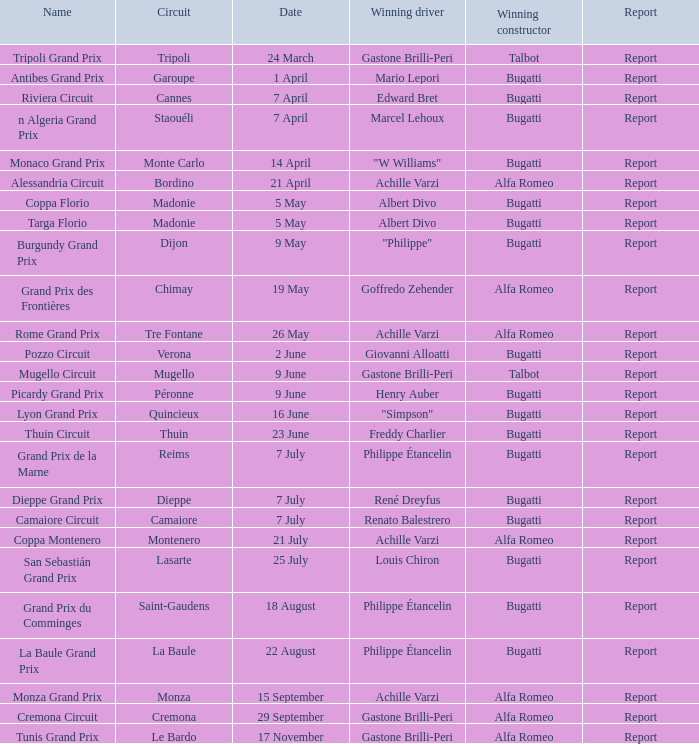What circuit possesses a date of 25 july? Lasarte. 